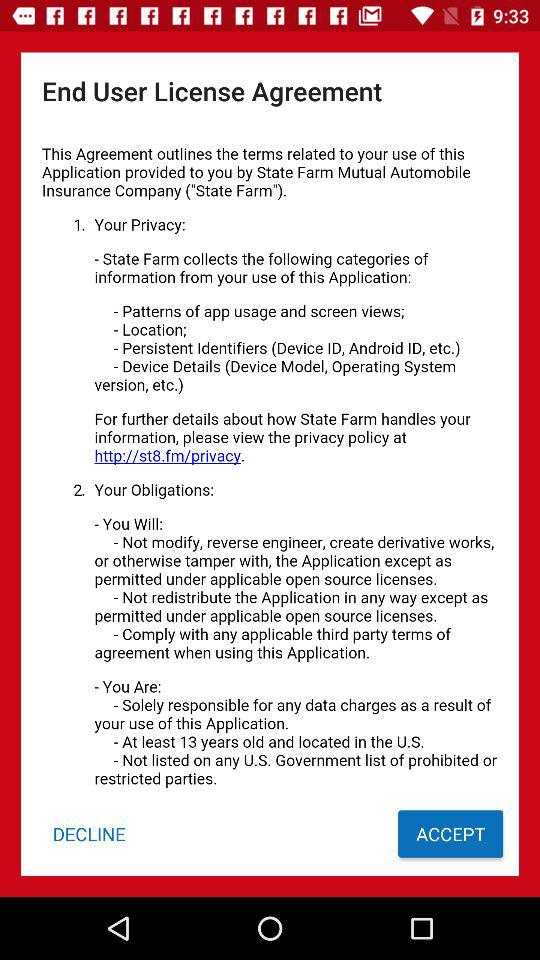Which website I can visit for more information?
When the provided information is insufficient, respond with <no answer>. <no answer> 